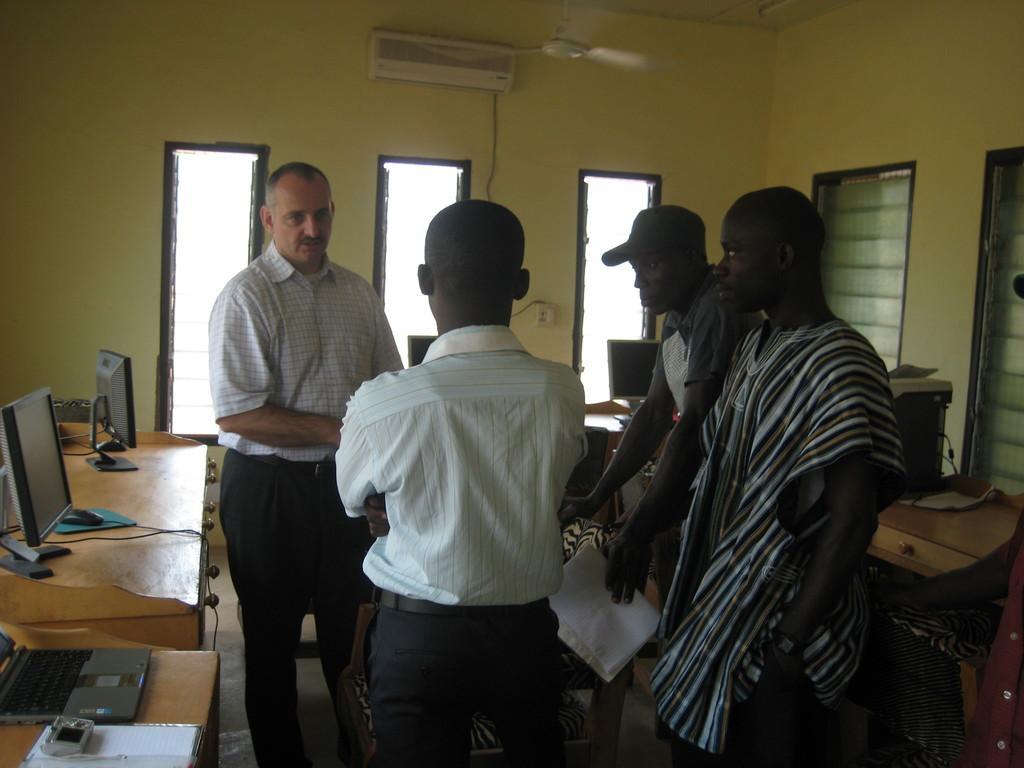How would you summarize this image in a sentence or two? In front of the image there are four people standing on the floor. In front of them there are chairs. There are tables. On top of it there are computers and some other objects. In the background of the image there are glass windows. There is an AC on the wall. On top of the image there is a fan. 